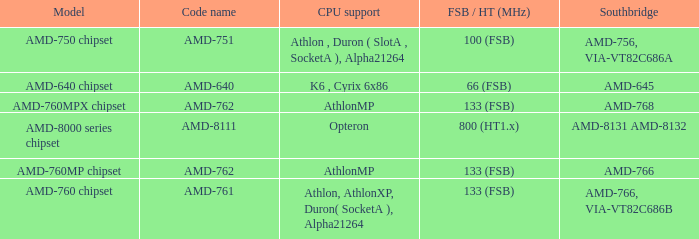What shows for Southbridge when the Model number is amd-640 chipset? AMD-645. 